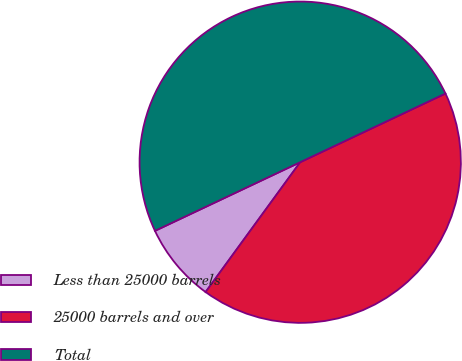Convert chart to OTSL. <chart><loc_0><loc_0><loc_500><loc_500><pie_chart><fcel>Less than 25000 barrels<fcel>25000 barrels and over<fcel>Total<nl><fcel>7.95%<fcel>42.05%<fcel>50.0%<nl></chart> 